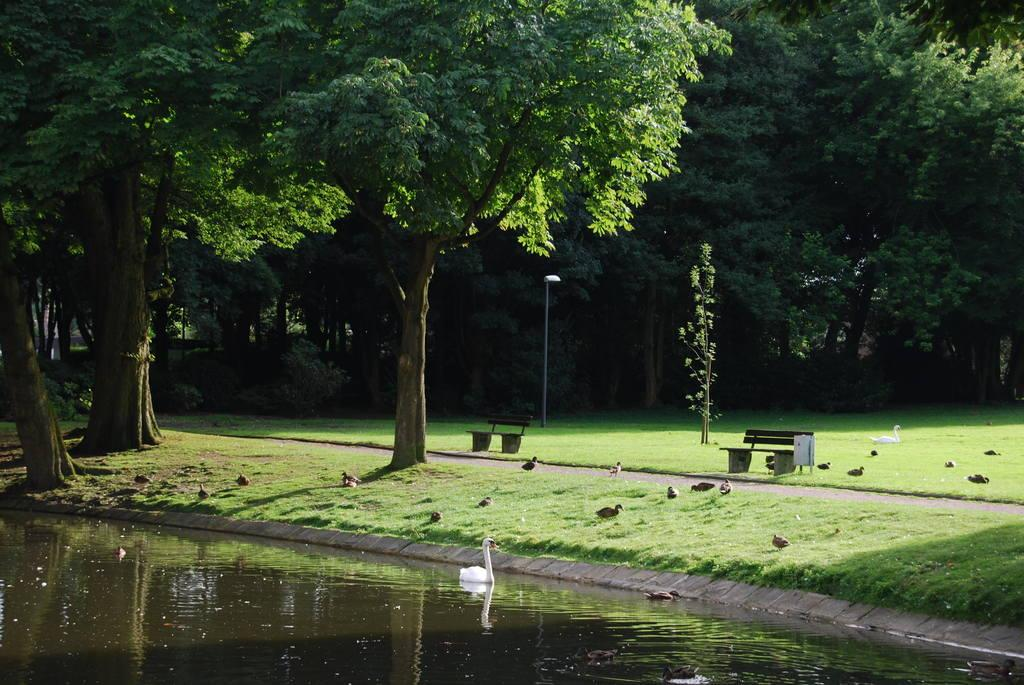What is located at the bottom of the picture? There is a lake in the bottom of the picture. What can be seen in the background of the picture? There are trees and grass in the background of the picture. How much profit did the pet make from the lake in the image? There is no pet or profit mentioned in the image, as it only features a lake and trees in the background. 